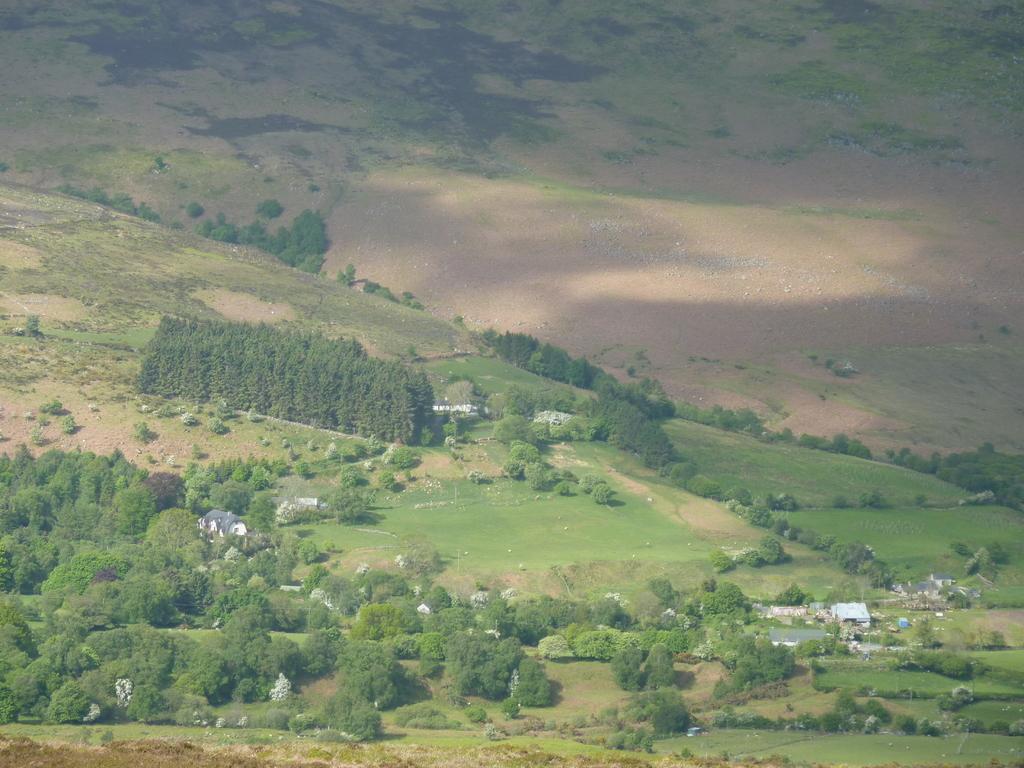How would you summarize this image in a sentence or two? This is an aerial view of an image where we can see grasslands, trees and houses here. 